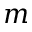Convert formula to latex. <formula><loc_0><loc_0><loc_500><loc_500>m</formula> 